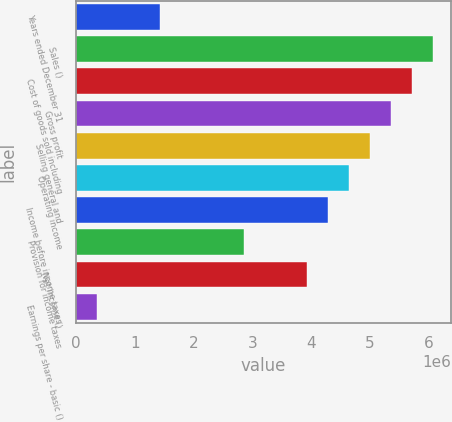<chart> <loc_0><loc_0><loc_500><loc_500><bar_chart><fcel>Years ended December 31<fcel>Sales ()<fcel>Cost of goods sold including<fcel>Gross profit<fcel>Selling general and<fcel>Operating income<fcel>Income before income taxes<fcel>Provision for income taxes<fcel>Net income ()<fcel>Earnings per share - basic ()<nl><fcel>1.43062e+06<fcel>6.08014e+06<fcel>5.72248e+06<fcel>5.36483e+06<fcel>5.00717e+06<fcel>4.64952e+06<fcel>4.29186e+06<fcel>2.86124e+06<fcel>3.93421e+06<fcel>357657<nl></chart> 